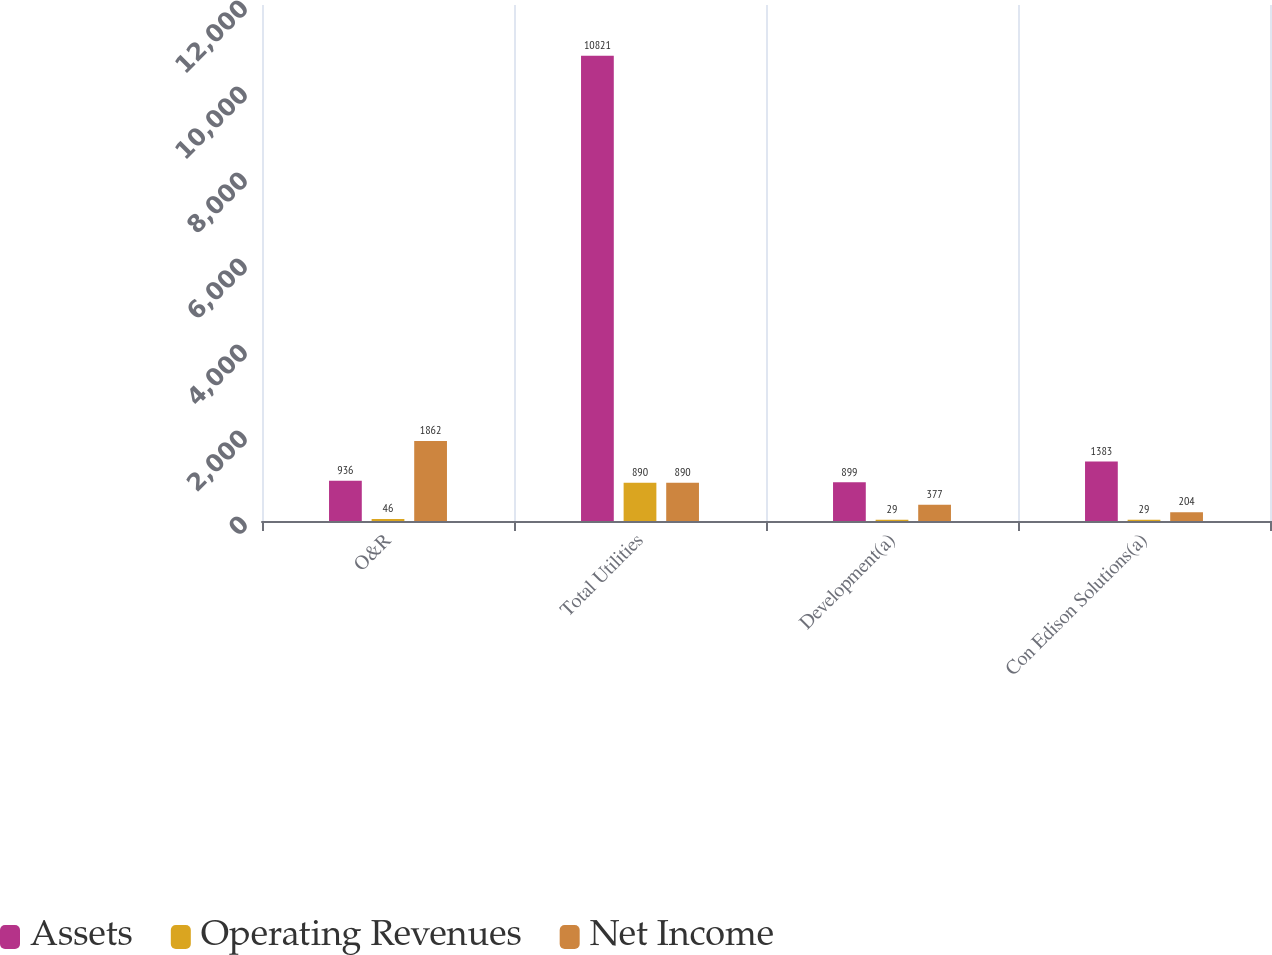<chart> <loc_0><loc_0><loc_500><loc_500><stacked_bar_chart><ecel><fcel>O&R<fcel>Total Utilities<fcel>Development(a)<fcel>Con Edison Solutions(a)<nl><fcel>Assets<fcel>936<fcel>10821<fcel>899<fcel>1383<nl><fcel>Operating Revenues<fcel>46<fcel>890<fcel>29<fcel>29<nl><fcel>Net Income<fcel>1862<fcel>890<fcel>377<fcel>204<nl></chart> 